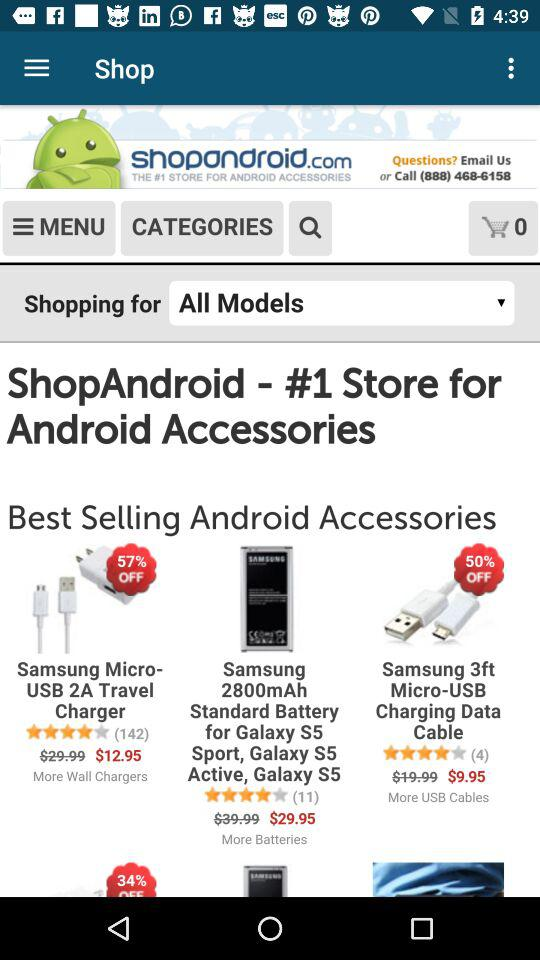What is the store name? The store name is "ShopAndroid". 